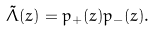<formula> <loc_0><loc_0><loc_500><loc_500>\tilde { \Lambda } ( z ) = p _ { + } ( z ) p _ { - } ( z ) .</formula> 